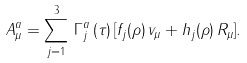<formula> <loc_0><loc_0><loc_500><loc_500>A _ { \mu } ^ { a } = \sum _ { j = 1 } ^ { 3 } \, \Gamma ^ { a } _ { j } \, ( \tau ) \, [ f _ { j } ( \rho ) \, v _ { \mu } + h _ { j } ( \rho ) \, R _ { \mu } ] .</formula> 